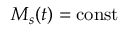Convert formula to latex. <formula><loc_0><loc_0><loc_500><loc_500>M _ { s } ( t ) = c o n s t</formula> 